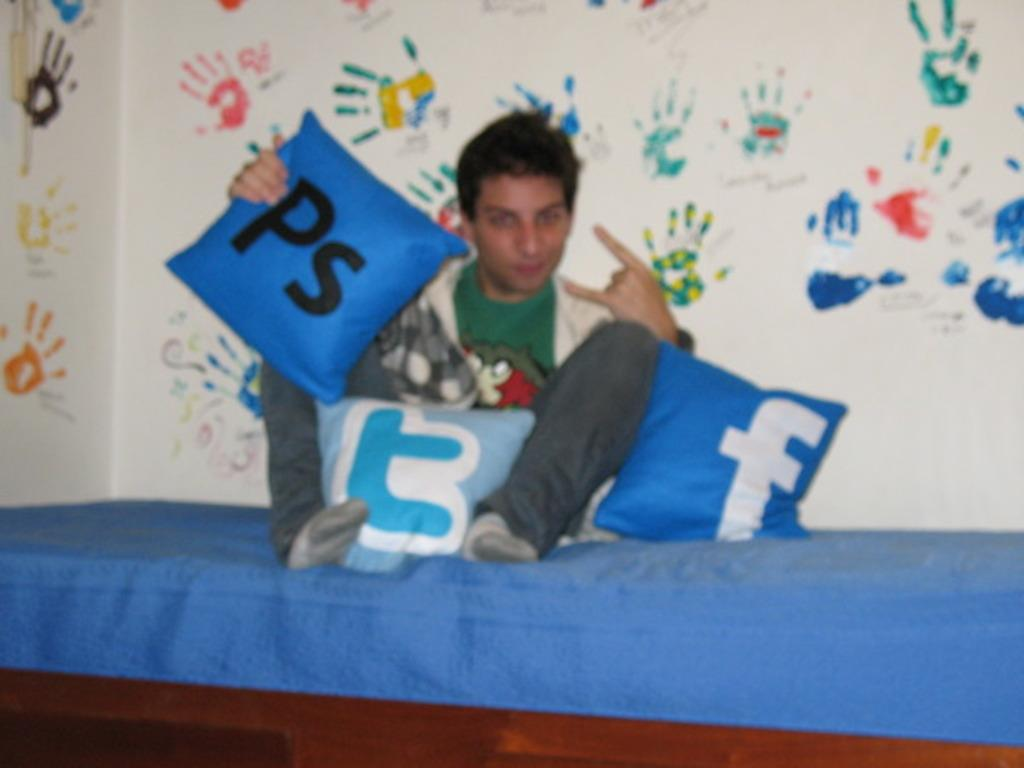<image>
Give a short and clear explanation of the subsequent image. a man with a pillow next to him that has the letter F on it 